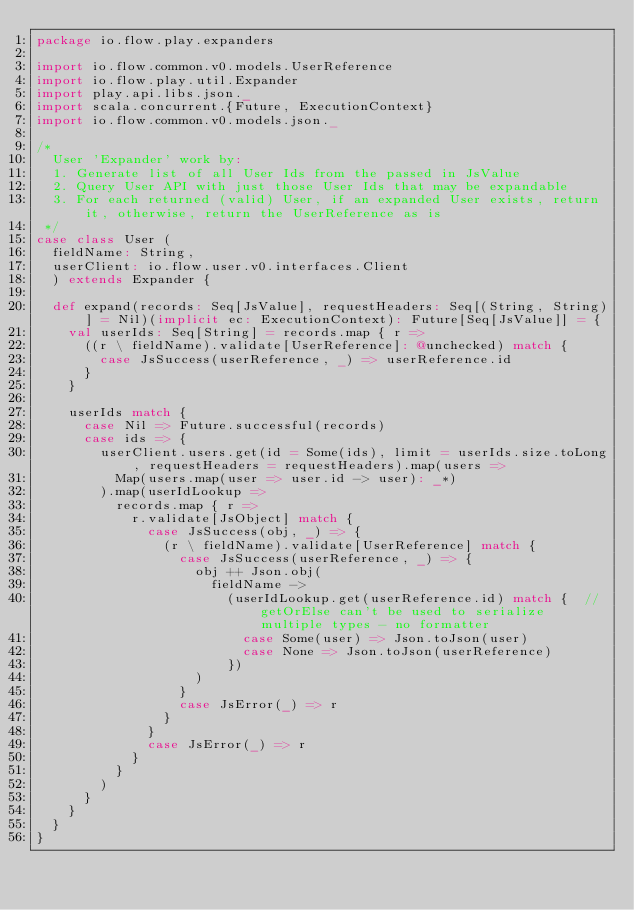Convert code to text. <code><loc_0><loc_0><loc_500><loc_500><_Scala_>package io.flow.play.expanders

import io.flow.common.v0.models.UserReference
import io.flow.play.util.Expander
import play.api.libs.json._
import scala.concurrent.{Future, ExecutionContext}
import io.flow.common.v0.models.json._

/*
  User 'Expander' work by:
  1. Generate list of all User Ids from the passed in JsValue
  2. Query User API with just those User Ids that may be expandable
  3. For each returned (valid) User, if an expanded User exists, return it, otherwise, return the UserReference as is
 */
case class User (
  fieldName: String,
  userClient: io.flow.user.v0.interfaces.Client
  ) extends Expander {

  def expand(records: Seq[JsValue], requestHeaders: Seq[(String, String)] = Nil)(implicit ec: ExecutionContext): Future[Seq[JsValue]] = {
    val userIds: Seq[String] = records.map { r =>
      ((r \ fieldName).validate[UserReference]: @unchecked) match {
        case JsSuccess(userReference, _) => userReference.id
      }
    }

    userIds match {
      case Nil => Future.successful(records)
      case ids => {
        userClient.users.get(id = Some(ids), limit = userIds.size.toLong, requestHeaders = requestHeaders).map(users =>
          Map(users.map(user => user.id -> user): _*)
        ).map(userIdLookup =>
          records.map { r =>
            r.validate[JsObject] match {
              case JsSuccess(obj, _) => {
                (r \ fieldName).validate[UserReference] match {
                  case JsSuccess(userReference, _) => {
                    obj ++ Json.obj(
                      fieldName ->
                        (userIdLookup.get(userReference.id) match {  //getOrElse can't be used to serialize multiple types - no formatter
                          case Some(user) => Json.toJson(user)
                          case None => Json.toJson(userReference)
                        })
                    )
                  }
                  case JsError(_) => r
                }
              }
              case JsError(_) => r
            }
          }
        )
      }
    }
  }
}
</code> 